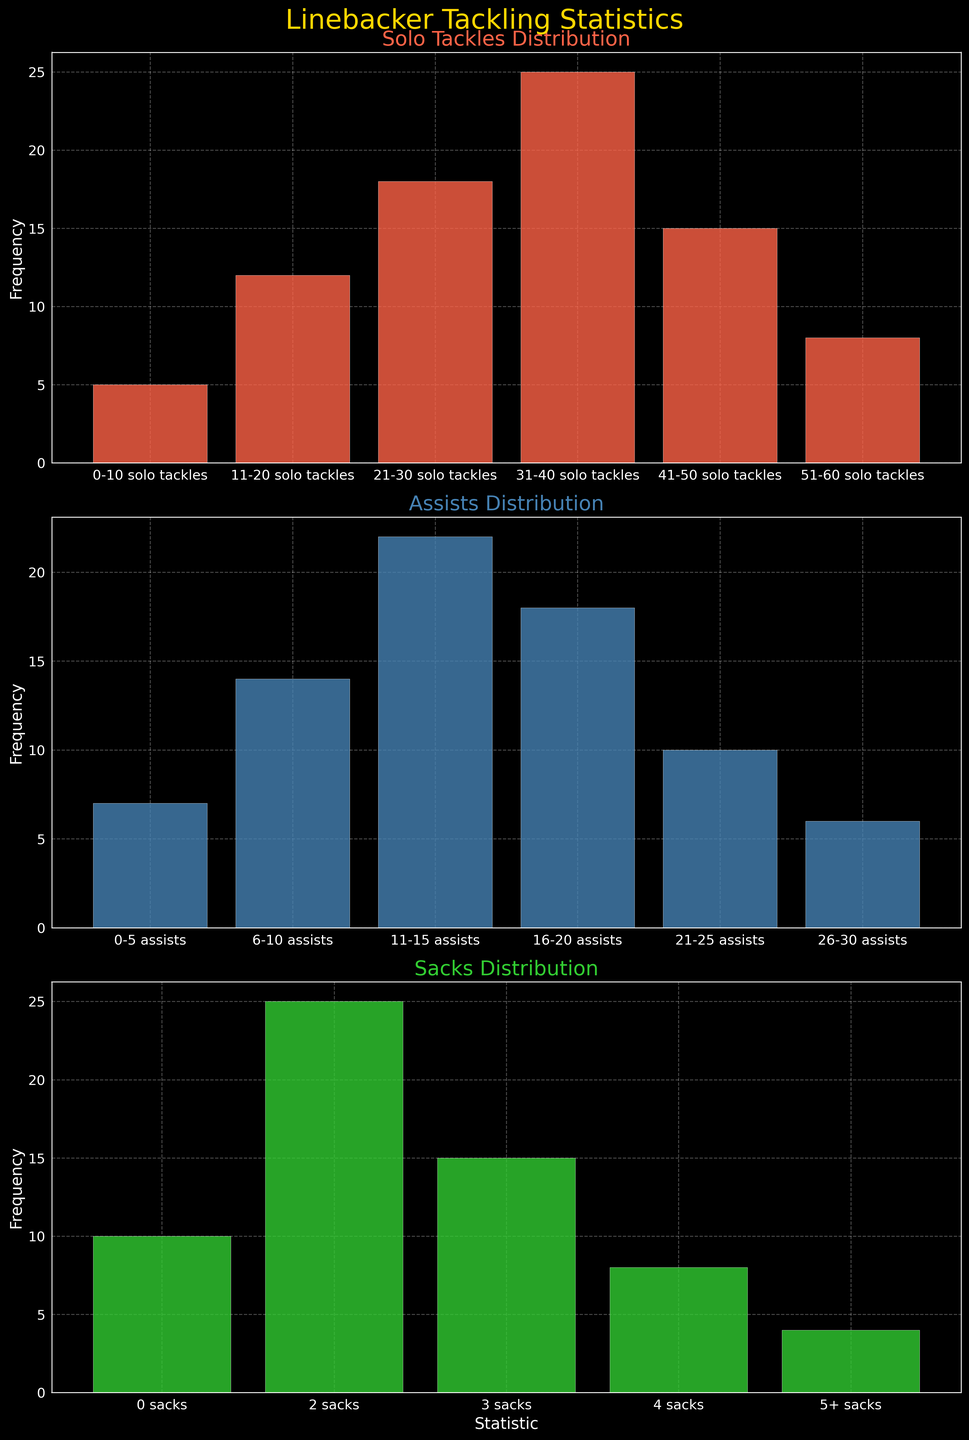Which statistic has the highest frequency in solo tackles? Look at the solo tackles bar chart and find the tallest bar. The solo tackles range with the tallest bar has the highest frequency.
Answer: 31-40 solo tackles What is the combined frequency for assists in the ranges 16-20 and 21-25? Refer to the assists bar chart and note the frequencies for 16-20 (18) and 21-25 (10). Add these values: 18 + 10 = 28.
Answer: 28 Which range has a higher frequency of sacks: 1 sack or 3 sacks? Compare the heights of the bars for 1 sack and 3 sacks in the sacks bar chart. The bar for 1 sack is taller.
Answer: 1 sack How many total linebackers made 51-60 solo tackles and 0-5 assists? Sum the frequencies of the 51-60 solo tackles (8) and 0-5 assists (7) from their respective bar charts: 8 + 7 = 15.
Answer: 15 What is the most common number of sacks achieved by linebackers? Check the sacks bar chart for the most frequent sack count by identifying the highest bar.
Answer: 2 sacks What's the total frequency of solo tackles for all ranges combined? Add the frequencies from each solo tackles range: 5 + 12 + 18 + 25 + 15 + 8 = 83.
Answer: 83 Compare the frequencies of assists in the ranges 6-10 and 11-15. Which is higher? Look at the assists bar chart, compare the heights of the bars for 6-10 (14) and 11-15 (22). The bar for 11-15 is higher.
Answer: 11-15 Which statistic distribution has more varied frequencies: solo tackles or sacks? Compare the range of frequencies in the solo tackles and sacks bar charts. Solo tackles have a wider range (from 5 to 25) compared to sacks (from 4 to 25).
Answer: solo tackles 